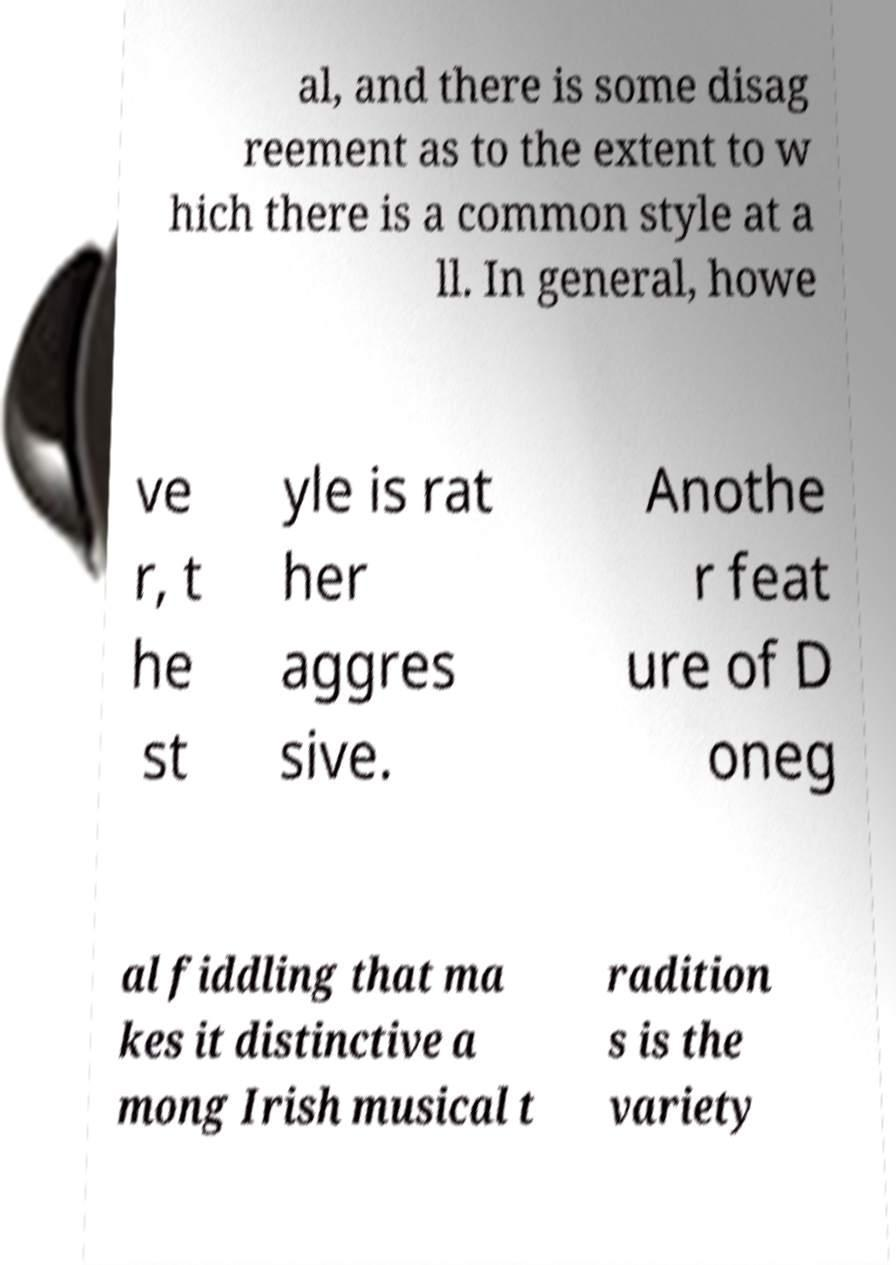I need the written content from this picture converted into text. Can you do that? al, and there is some disag reement as to the extent to w hich there is a common style at a ll. In general, howe ve r, t he st yle is rat her aggres sive. Anothe r feat ure of D oneg al fiddling that ma kes it distinctive a mong Irish musical t radition s is the variety 